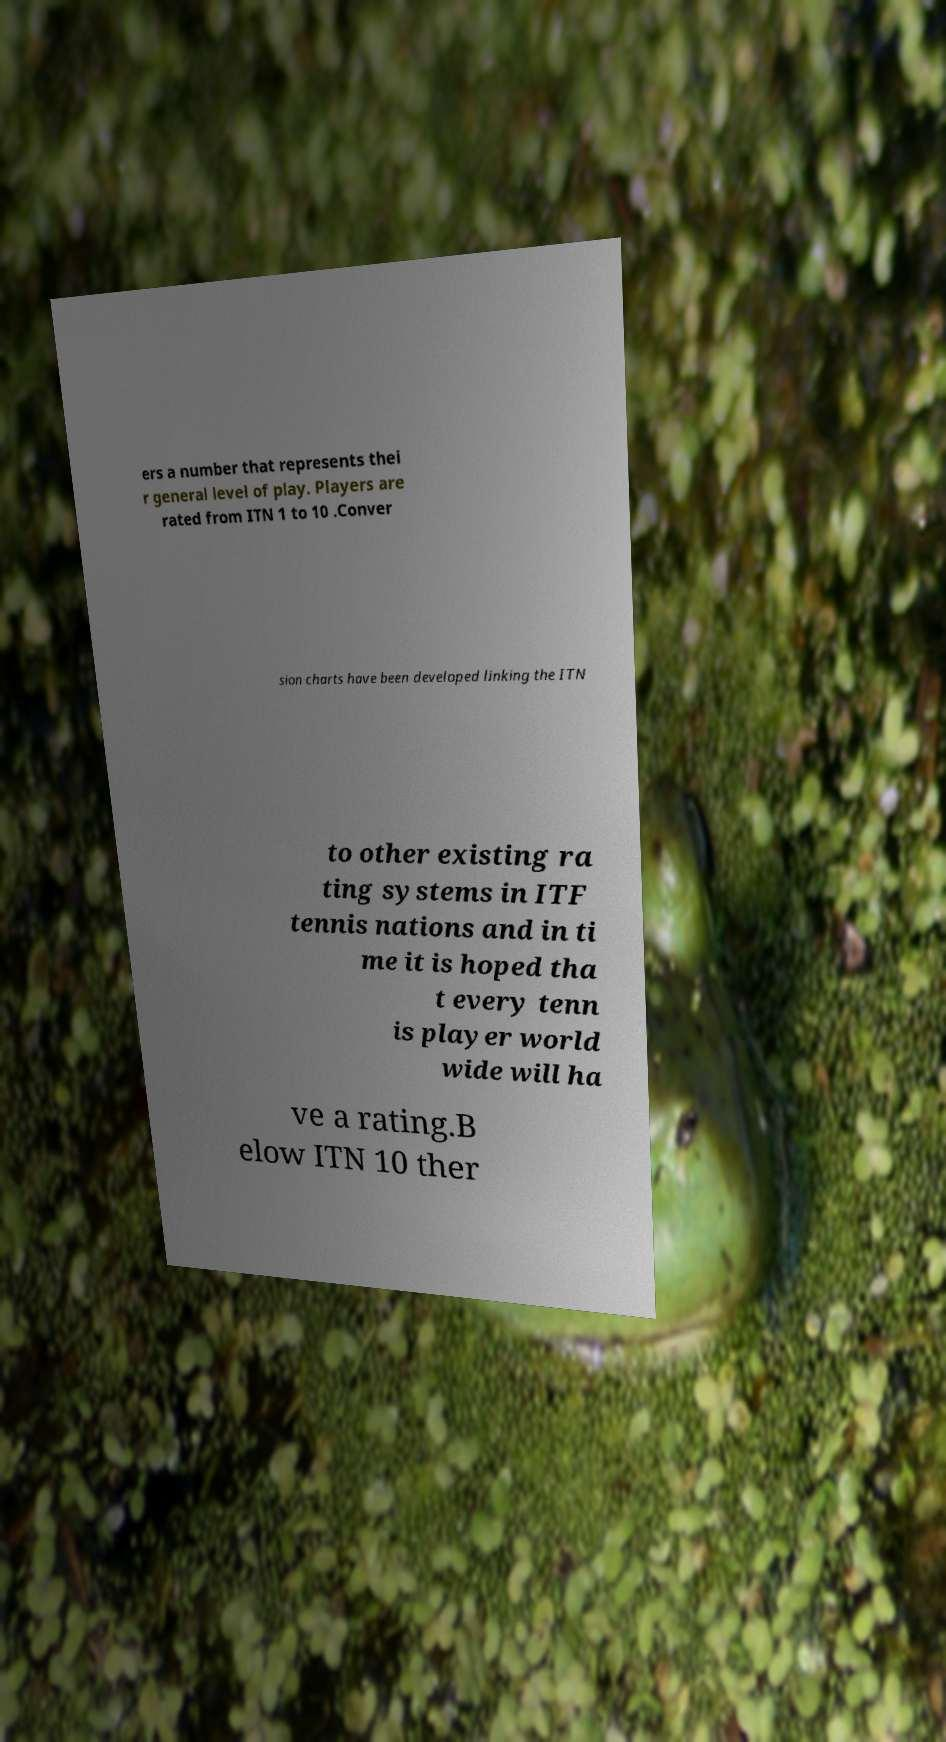Could you extract and type out the text from this image? ers a number that represents thei r general level of play. Players are rated from ITN 1 to 10 .Conver sion charts have been developed linking the ITN to other existing ra ting systems in ITF tennis nations and in ti me it is hoped tha t every tenn is player world wide will ha ve a rating.B elow ITN 10 ther 